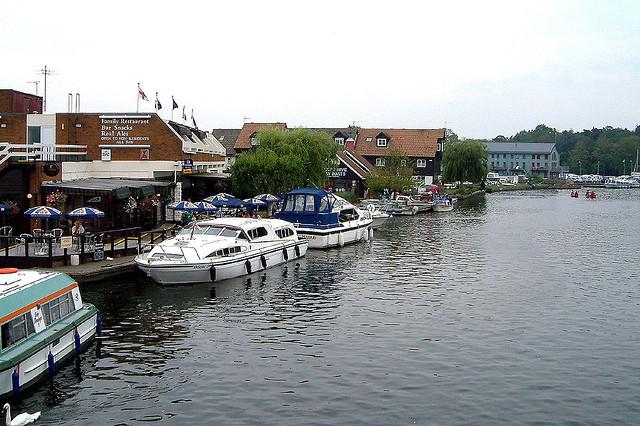Is this a harbor?
Short answer required. Yes. Is the water calm or rough?
Give a very brief answer. Calm. How many boats are in the foreground?
Be succinct. 3. 